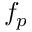<formula> <loc_0><loc_0><loc_500><loc_500>f _ { p }</formula> 